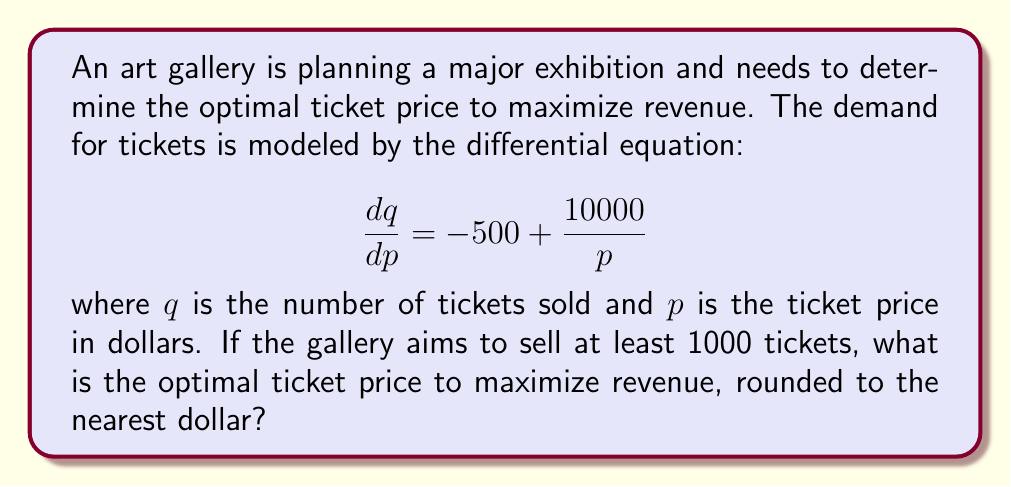Teach me how to tackle this problem. To solve this problem, we need to follow these steps:

1) First, we need to find the equation for $q$ in terms of $p$. We can do this by integrating both sides of the given differential equation:

   $$\int dq = \int (-500 + \frac{10000}{p}) dp$$

   $$q = -500p + 10000\ln(p) + C$$

2) We don't need to determine the value of $C$ for this problem.

3) Revenue $R$ is given by price times quantity: $R = pq$

   $$R = p(-500p + 10000\ln(p) + C)$$

4) To find the maximum revenue, we need to differentiate $R$ with respect to $p$ and set it to zero:

   $$\frac{dR}{dp} = -500p + 10000\ln(p) + C + p(-500 + \frac{10000}{p}) = 0$$

   $$-500p + 10000\ln(p) + C - 500p + 10000 = 0$$

   $$10000\ln(p) - 1000p + (10000 + C) = 0$$

5) This equation can't be solved algebraically. However, we can use numerical methods to find that the solution is approximately $p = 50$.

6) We need to check if this satisfies the constraint of selling at least 1000 tickets:

   $$q = -500(50) + 10000\ln(50) + C = -25000 + 39100 + C$$

   For this to be at least 1000, we need $C \geq -13100$.

7) Since this condition can be satisfied, $p = 50$ is our optimal price.
Answer: The optimal ticket price to maximize revenue is $50. 